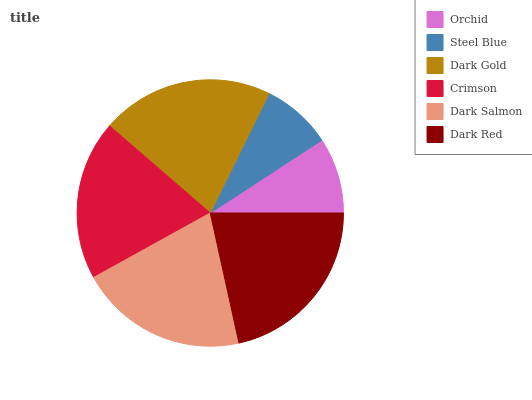Is Steel Blue the minimum?
Answer yes or no. Yes. Is Dark Red the maximum?
Answer yes or no. Yes. Is Dark Gold the minimum?
Answer yes or no. No. Is Dark Gold the maximum?
Answer yes or no. No. Is Dark Gold greater than Steel Blue?
Answer yes or no. Yes. Is Steel Blue less than Dark Gold?
Answer yes or no. Yes. Is Steel Blue greater than Dark Gold?
Answer yes or no. No. Is Dark Gold less than Steel Blue?
Answer yes or no. No. Is Dark Salmon the high median?
Answer yes or no. Yes. Is Crimson the low median?
Answer yes or no. Yes. Is Dark Gold the high median?
Answer yes or no. No. Is Steel Blue the low median?
Answer yes or no. No. 